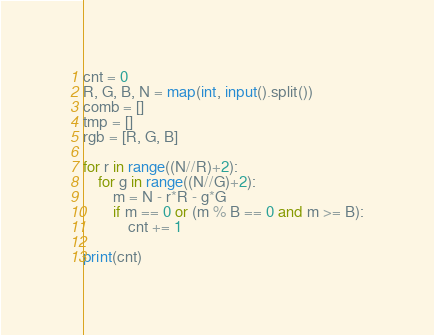<code> <loc_0><loc_0><loc_500><loc_500><_Python_>cnt = 0
R, G, B, N = map(int, input().split())
comb = []
tmp = []
rgb = [R, G, B]

for r in range((N//R)+2):
    for g in range((N//G)+2):
        m = N - r*R - g*G
        if m == 0 or (m % B == 0 and m >= B):
            cnt += 1

print(cnt)</code> 